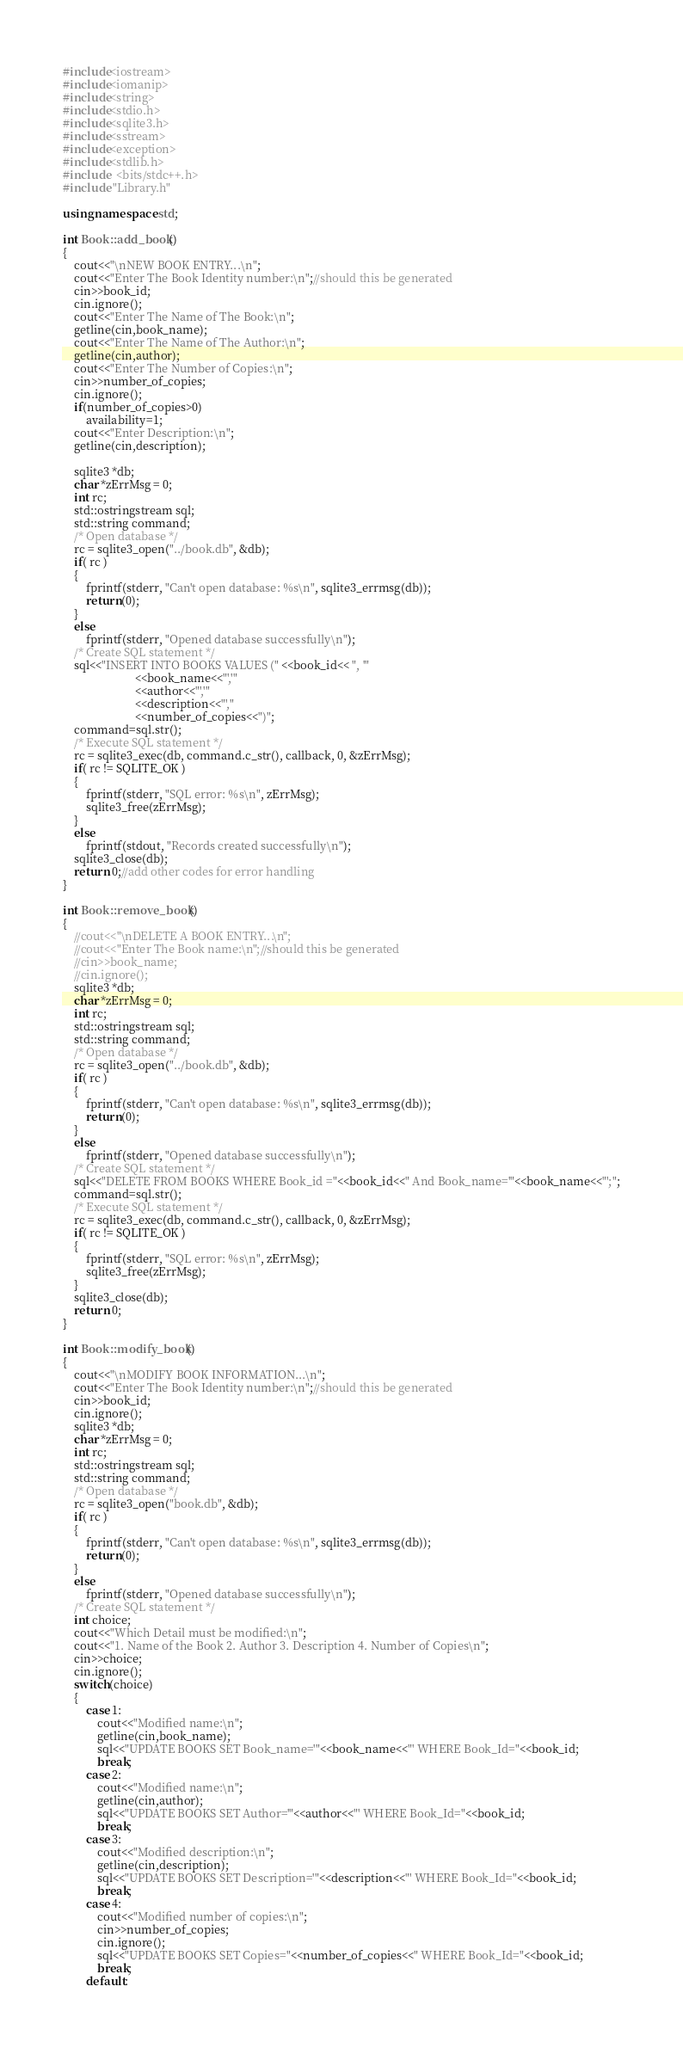Convert code to text. <code><loc_0><loc_0><loc_500><loc_500><_C++_>#include<iostream>
#include<iomanip>
#include<string>
#include<stdio.h>
#include<sqlite3.h>
#include<sstream>
#include<exception>
#include<stdlib.h>
#include  <bits/stdc++.h>
#include "Library.h"

using namespace std;

int Book::add_book()
{
	cout<<"\nNEW BOOK ENTRY...\n";
	cout<<"Enter The Book Identity number:\n";//should this be generated
	cin>>book_id;
	cin.ignore();
	cout<<"Enter The Name of The Book:\n";
	getline(cin,book_name);
	cout<<"Enter The Name of The Author:\n";
	getline(cin,author);
	cout<<"Enter The Number of Copies:\n";
	cin>>number_of_copies;
	cin.ignore();
	if(number_of_copies>0)
		availability=1;
	cout<<"Enter Description:\n";
	getline(cin,description);

	sqlite3 *db;
	char *zErrMsg = 0;
	int rc;
	std::ostringstream sql;
	std::string command;
	/* Open database */
   	rc = sqlite3_open("../book.db", &db);
   	if( rc ) 
	{
		fprintf(stderr, "Can't open database: %s\n", sqlite3_errmsg(db));
		return(0);
	} 
	else 
		fprintf(stderr, "Opened database successfully\n");
	/* Create SQL statement */
	sql<<"INSERT INTO BOOKS VALUES (" <<book_id<< ", '" 
						 <<book_name<<"','"
						 <<author<<"','"
						 <<description<<"',"
						 <<number_of_copies<<")";
	command=sql.str();
	/* Execute SQL statement */
	rc = sqlite3_exec(db, command.c_str(), callback, 0, &zErrMsg);   
	if( rc != SQLITE_OK )
	{
		fprintf(stderr, "SQL error: %s\n", zErrMsg);
		sqlite3_free(zErrMsg);
	} 
	else
		fprintf(stdout, "Records created successfully\n");
	sqlite3_close(db);
	return 0;//add other codes for error handling
}

int Book::remove_book()
{
	//cout<<"\nDELETE A BOOK ENTRY...\n";
	//cout<<"Enter The Book name:\n";//should this be generated
	//cin>>book_name;
	//cin.ignore();
	sqlite3 *db;
	char *zErrMsg = 0;
	int rc;
	std::ostringstream sql;
	std::string command;
	/* Open database */
   	rc = sqlite3_open("../book.db", &db);
   	if( rc ) 
	{
		fprintf(stderr, "Can't open database: %s\n", sqlite3_errmsg(db));
		return(0);
	} 
	else 
		fprintf(stderr, "Opened database successfully\n");
	/* Create SQL statement */
	sql<<"DELETE FROM BOOKS WHERE Book_id ="<<book_id<<" And Book_name='"<<book_name<<"';";
	command=sql.str();
	/* Execute SQL statement */
	rc = sqlite3_exec(db, command.c_str(), callback, 0, &zErrMsg);   
	if( rc != SQLITE_OK )
	{
		fprintf(stderr, "SQL error: %s\n", zErrMsg);
		sqlite3_free(zErrMsg);
	} 
	sqlite3_close(db);
	return 0;
}

int Book::modify_book()
{
	cout<<"\nMODIFY BOOK INFORMATION...\n";
	cout<<"Enter The Book Identity number:\n";//should this be generated
	cin>>book_id;
	cin.ignore();
	sqlite3 *db;
	char *zErrMsg = 0;
	int rc;
	std::ostringstream sql;
	std::string command;
	/* Open database */
   	rc = sqlite3_open("book.db", &db);
   	if( rc ) 
	{
		fprintf(stderr, "Can't open database: %s\n", sqlite3_errmsg(db));
		return(0);
	} 
	else 
		fprintf(stderr, "Opened database successfully\n");
	/* Create SQL statement */
	int choice;
	cout<<"Which Detail must be modified:\n";
	cout<<"1. Name of the Book 2. Author 3. Description 4. Number of Copies\n";
	cin>>choice;
	cin.ignore();
	switch(choice)
	{
		case 1:
			cout<<"Modified name:\n";
			getline(cin,book_name);
			sql<<"UPDATE BOOKS SET Book_name='"<<book_name<<"' WHERE Book_Id="<<book_id;
			break;
		case 2:
			cout<<"Modified name:\n";
			getline(cin,author);
			sql<<"UPDATE BOOKS SET Author='"<<author<<"' WHERE Book_Id="<<book_id;
			break;
		case 3:
			cout<<"Modified description:\n";
			getline(cin,description);
			sql<<"UPDATE BOOKS SET Description='"<<description<<"' WHERE Book_Id="<<book_id;
			break;
		case 4:
			cout<<"Modified number of copies:\n";
			cin>>number_of_copies;
			cin.ignore();
			sql<<"UPDATE BOOKS SET Copies="<<number_of_copies<<" WHERE Book_Id="<<book_id;
			break;	
		default:</code> 